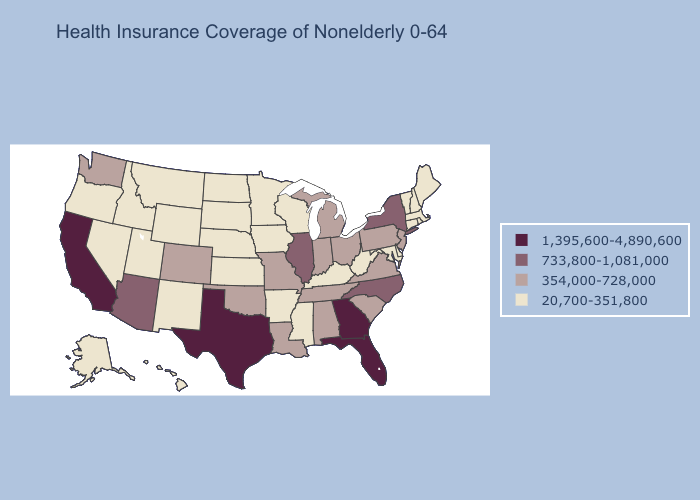Name the states that have a value in the range 733,800-1,081,000?
Quick response, please. Arizona, Illinois, New York, North Carolina. Which states have the lowest value in the USA?
Quick response, please. Alaska, Arkansas, Connecticut, Delaware, Hawaii, Idaho, Iowa, Kansas, Kentucky, Maine, Maryland, Massachusetts, Minnesota, Mississippi, Montana, Nebraska, Nevada, New Hampshire, New Mexico, North Dakota, Oregon, Rhode Island, South Dakota, Utah, Vermont, West Virginia, Wisconsin, Wyoming. Does New York have the lowest value in the Northeast?
Concise answer only. No. What is the highest value in the West ?
Answer briefly. 1,395,600-4,890,600. Does Florida have the highest value in the USA?
Be succinct. Yes. Among the states that border Illinois , does Indiana have the lowest value?
Give a very brief answer. No. Among the states that border Texas , does New Mexico have the highest value?
Answer briefly. No. Name the states that have a value in the range 733,800-1,081,000?
Give a very brief answer. Arizona, Illinois, New York, North Carolina. What is the value of Kansas?
Be succinct. 20,700-351,800. Among the states that border Texas , does Arkansas have the highest value?
Concise answer only. No. Name the states that have a value in the range 1,395,600-4,890,600?
Concise answer only. California, Florida, Georgia, Texas. Among the states that border North Carolina , which have the lowest value?
Answer briefly. South Carolina, Tennessee, Virginia. Does Illinois have the highest value in the MidWest?
Quick response, please. Yes. Name the states that have a value in the range 20,700-351,800?
Be succinct. Alaska, Arkansas, Connecticut, Delaware, Hawaii, Idaho, Iowa, Kansas, Kentucky, Maine, Maryland, Massachusetts, Minnesota, Mississippi, Montana, Nebraska, Nevada, New Hampshire, New Mexico, North Dakota, Oregon, Rhode Island, South Dakota, Utah, Vermont, West Virginia, Wisconsin, Wyoming. What is the value of South Carolina?
Concise answer only. 354,000-728,000. 